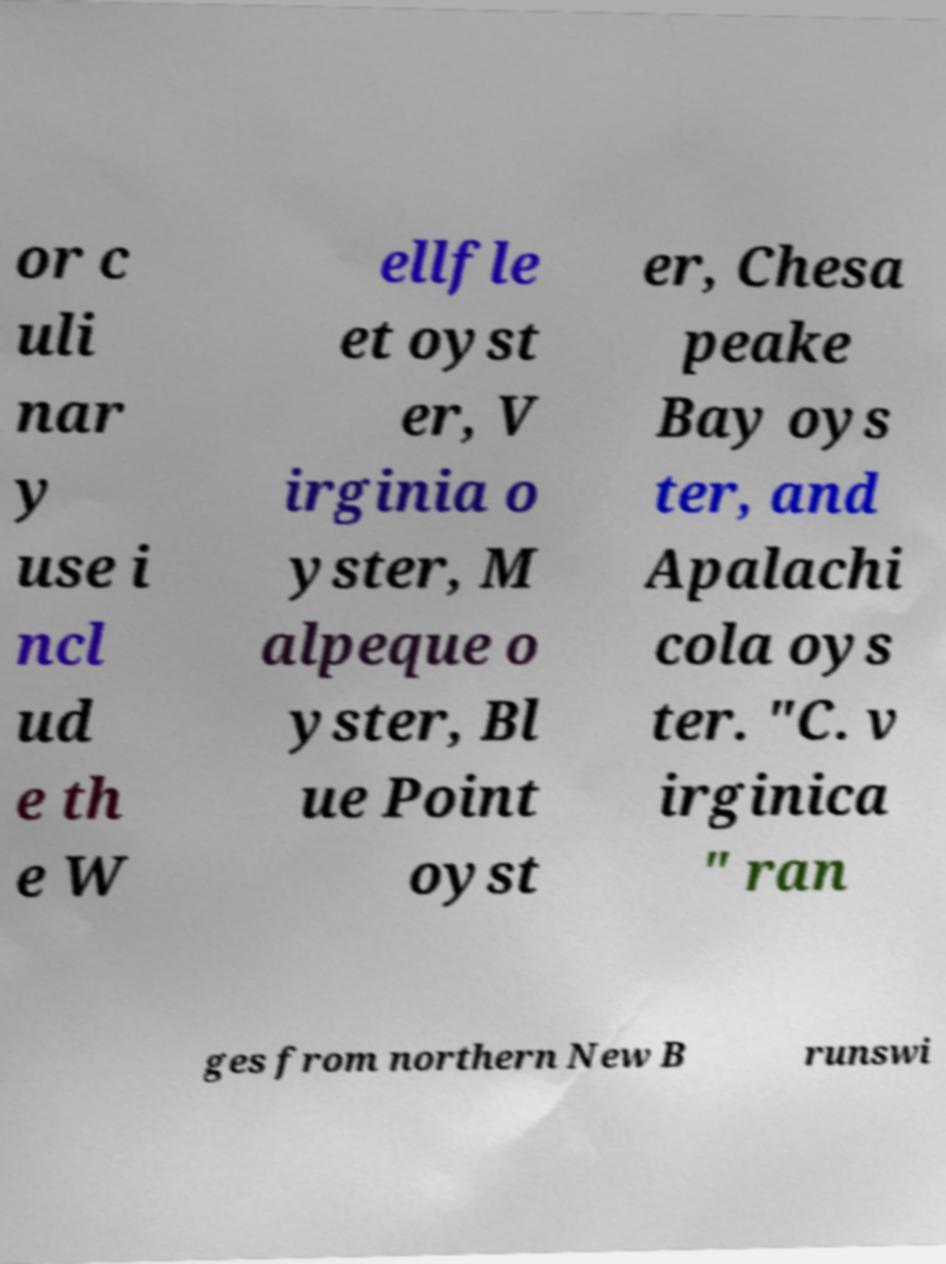There's text embedded in this image that I need extracted. Can you transcribe it verbatim? or c uli nar y use i ncl ud e th e W ellfle et oyst er, V irginia o yster, M alpeque o yster, Bl ue Point oyst er, Chesa peake Bay oys ter, and Apalachi cola oys ter. "C. v irginica " ran ges from northern New B runswi 